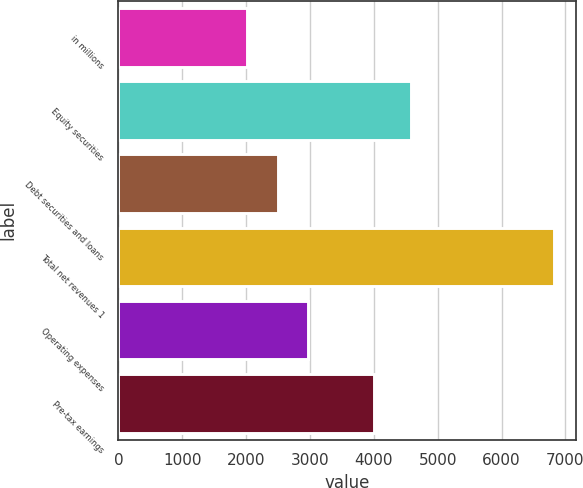Convert chart to OTSL. <chart><loc_0><loc_0><loc_500><loc_500><bar_chart><fcel>in millions<fcel>Equity securities<fcel>Debt securities and loans<fcel>Total net revenues 1<fcel>Operating expenses<fcel>Pre-tax earnings<nl><fcel>2014<fcel>4579<fcel>2495.1<fcel>6825<fcel>2976.2<fcel>4006<nl></chart> 